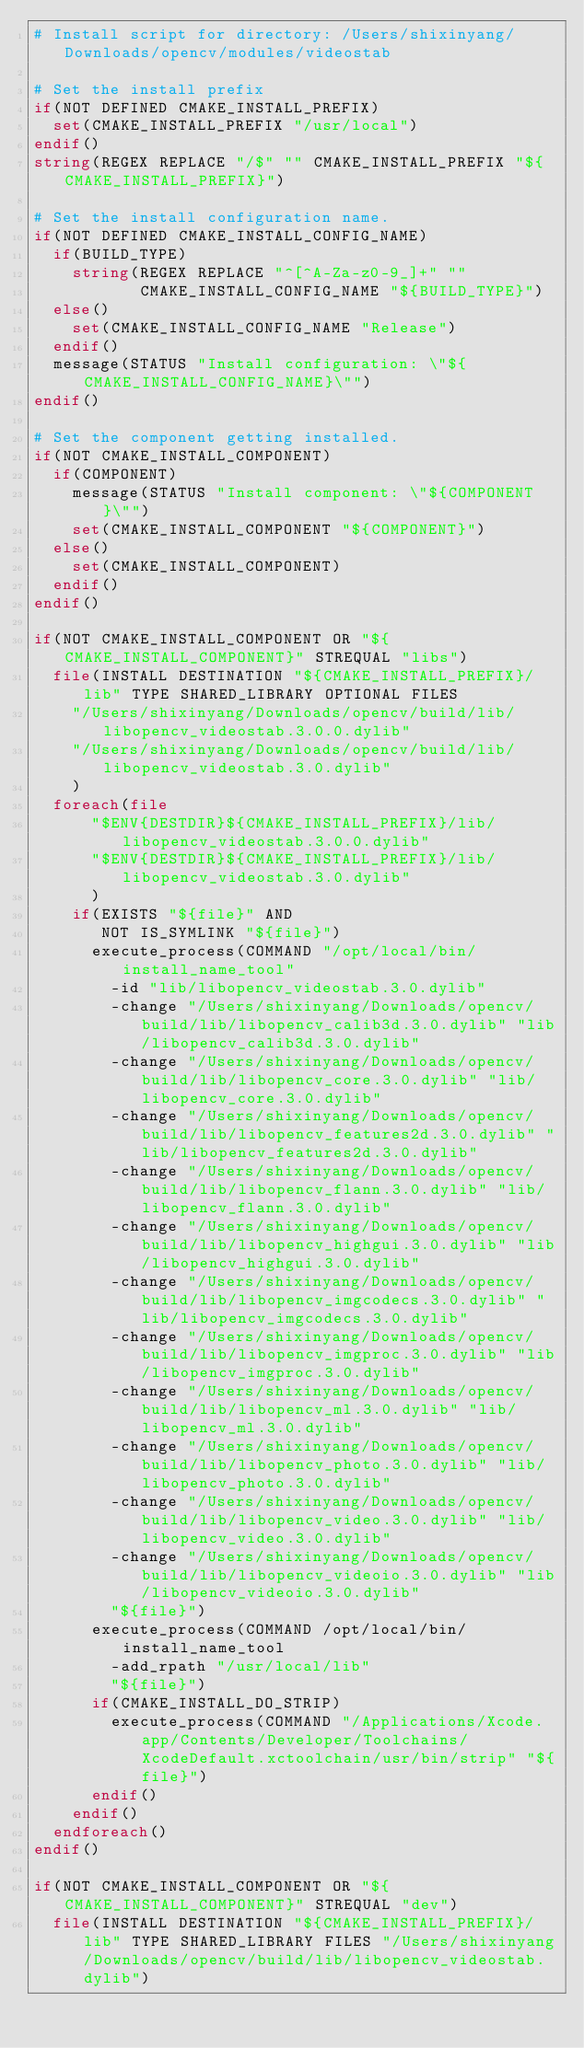<code> <loc_0><loc_0><loc_500><loc_500><_CMake_># Install script for directory: /Users/shixinyang/Downloads/opencv/modules/videostab

# Set the install prefix
if(NOT DEFINED CMAKE_INSTALL_PREFIX)
  set(CMAKE_INSTALL_PREFIX "/usr/local")
endif()
string(REGEX REPLACE "/$" "" CMAKE_INSTALL_PREFIX "${CMAKE_INSTALL_PREFIX}")

# Set the install configuration name.
if(NOT DEFINED CMAKE_INSTALL_CONFIG_NAME)
  if(BUILD_TYPE)
    string(REGEX REPLACE "^[^A-Za-z0-9_]+" ""
           CMAKE_INSTALL_CONFIG_NAME "${BUILD_TYPE}")
  else()
    set(CMAKE_INSTALL_CONFIG_NAME "Release")
  endif()
  message(STATUS "Install configuration: \"${CMAKE_INSTALL_CONFIG_NAME}\"")
endif()

# Set the component getting installed.
if(NOT CMAKE_INSTALL_COMPONENT)
  if(COMPONENT)
    message(STATUS "Install component: \"${COMPONENT}\"")
    set(CMAKE_INSTALL_COMPONENT "${COMPONENT}")
  else()
    set(CMAKE_INSTALL_COMPONENT)
  endif()
endif()

if(NOT CMAKE_INSTALL_COMPONENT OR "${CMAKE_INSTALL_COMPONENT}" STREQUAL "libs")
  file(INSTALL DESTINATION "${CMAKE_INSTALL_PREFIX}/lib" TYPE SHARED_LIBRARY OPTIONAL FILES
    "/Users/shixinyang/Downloads/opencv/build/lib/libopencv_videostab.3.0.0.dylib"
    "/Users/shixinyang/Downloads/opencv/build/lib/libopencv_videostab.3.0.dylib"
    )
  foreach(file
      "$ENV{DESTDIR}${CMAKE_INSTALL_PREFIX}/lib/libopencv_videostab.3.0.0.dylib"
      "$ENV{DESTDIR}${CMAKE_INSTALL_PREFIX}/lib/libopencv_videostab.3.0.dylib"
      )
    if(EXISTS "${file}" AND
       NOT IS_SYMLINK "${file}")
      execute_process(COMMAND "/opt/local/bin/install_name_tool"
        -id "lib/libopencv_videostab.3.0.dylib"
        -change "/Users/shixinyang/Downloads/opencv/build/lib/libopencv_calib3d.3.0.dylib" "lib/libopencv_calib3d.3.0.dylib"
        -change "/Users/shixinyang/Downloads/opencv/build/lib/libopencv_core.3.0.dylib" "lib/libopencv_core.3.0.dylib"
        -change "/Users/shixinyang/Downloads/opencv/build/lib/libopencv_features2d.3.0.dylib" "lib/libopencv_features2d.3.0.dylib"
        -change "/Users/shixinyang/Downloads/opencv/build/lib/libopencv_flann.3.0.dylib" "lib/libopencv_flann.3.0.dylib"
        -change "/Users/shixinyang/Downloads/opencv/build/lib/libopencv_highgui.3.0.dylib" "lib/libopencv_highgui.3.0.dylib"
        -change "/Users/shixinyang/Downloads/opencv/build/lib/libopencv_imgcodecs.3.0.dylib" "lib/libopencv_imgcodecs.3.0.dylib"
        -change "/Users/shixinyang/Downloads/opencv/build/lib/libopencv_imgproc.3.0.dylib" "lib/libopencv_imgproc.3.0.dylib"
        -change "/Users/shixinyang/Downloads/opencv/build/lib/libopencv_ml.3.0.dylib" "lib/libopencv_ml.3.0.dylib"
        -change "/Users/shixinyang/Downloads/opencv/build/lib/libopencv_photo.3.0.dylib" "lib/libopencv_photo.3.0.dylib"
        -change "/Users/shixinyang/Downloads/opencv/build/lib/libopencv_video.3.0.dylib" "lib/libopencv_video.3.0.dylib"
        -change "/Users/shixinyang/Downloads/opencv/build/lib/libopencv_videoio.3.0.dylib" "lib/libopencv_videoio.3.0.dylib"
        "${file}")
      execute_process(COMMAND /opt/local/bin/install_name_tool
        -add_rpath "/usr/local/lib"
        "${file}")
      if(CMAKE_INSTALL_DO_STRIP)
        execute_process(COMMAND "/Applications/Xcode.app/Contents/Developer/Toolchains/XcodeDefault.xctoolchain/usr/bin/strip" "${file}")
      endif()
    endif()
  endforeach()
endif()

if(NOT CMAKE_INSTALL_COMPONENT OR "${CMAKE_INSTALL_COMPONENT}" STREQUAL "dev")
  file(INSTALL DESTINATION "${CMAKE_INSTALL_PREFIX}/lib" TYPE SHARED_LIBRARY FILES "/Users/shixinyang/Downloads/opencv/build/lib/libopencv_videostab.dylib")</code> 